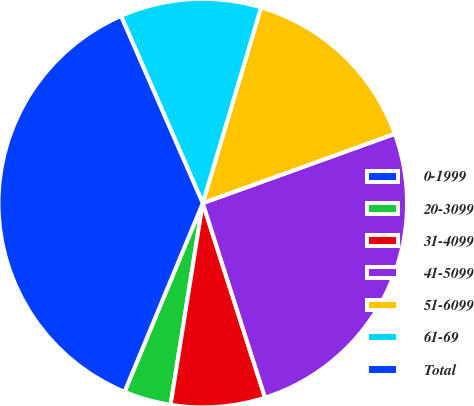<chart> <loc_0><loc_0><loc_500><loc_500><pie_chart><fcel>0-1999<fcel>20-3099<fcel>31-4099<fcel>41-5099<fcel>51-6099<fcel>61-69<fcel>Total<nl><fcel>0.01%<fcel>3.73%<fcel>7.45%<fcel>25.58%<fcel>14.88%<fcel>11.16%<fcel>37.19%<nl></chart> 